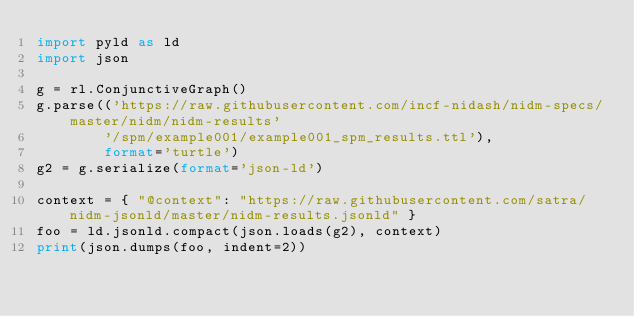<code> <loc_0><loc_0><loc_500><loc_500><_Python_>import pyld as ld
import json

g = rl.ConjunctiveGraph()
g.parse(('https://raw.githubusercontent.com/incf-nidash/nidm-specs/master/nidm/nidm-results'
        '/spm/example001/example001_spm_results.ttl'), 
        format='turtle')
g2 = g.serialize(format='json-ld')

context = { "@context": "https://raw.githubusercontent.com/satra/nidm-jsonld/master/nidm-results.jsonld" }
foo = ld.jsonld.compact(json.loads(g2), context)
print(json.dumps(foo, indent=2))</code> 